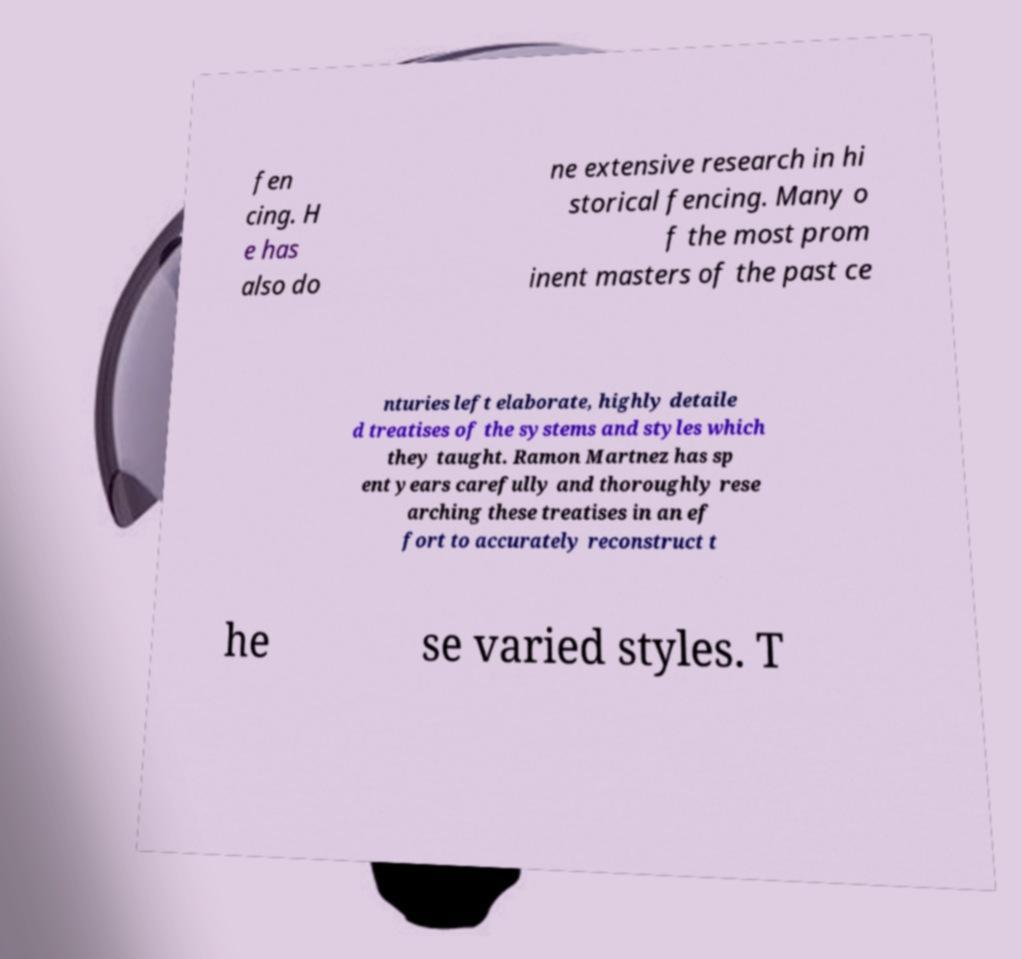Could you assist in decoding the text presented in this image and type it out clearly? fen cing. H e has also do ne extensive research in hi storical fencing. Many o f the most prom inent masters of the past ce nturies left elaborate, highly detaile d treatises of the systems and styles which they taught. Ramon Martnez has sp ent years carefully and thoroughly rese arching these treatises in an ef fort to accurately reconstruct t he se varied styles. T 